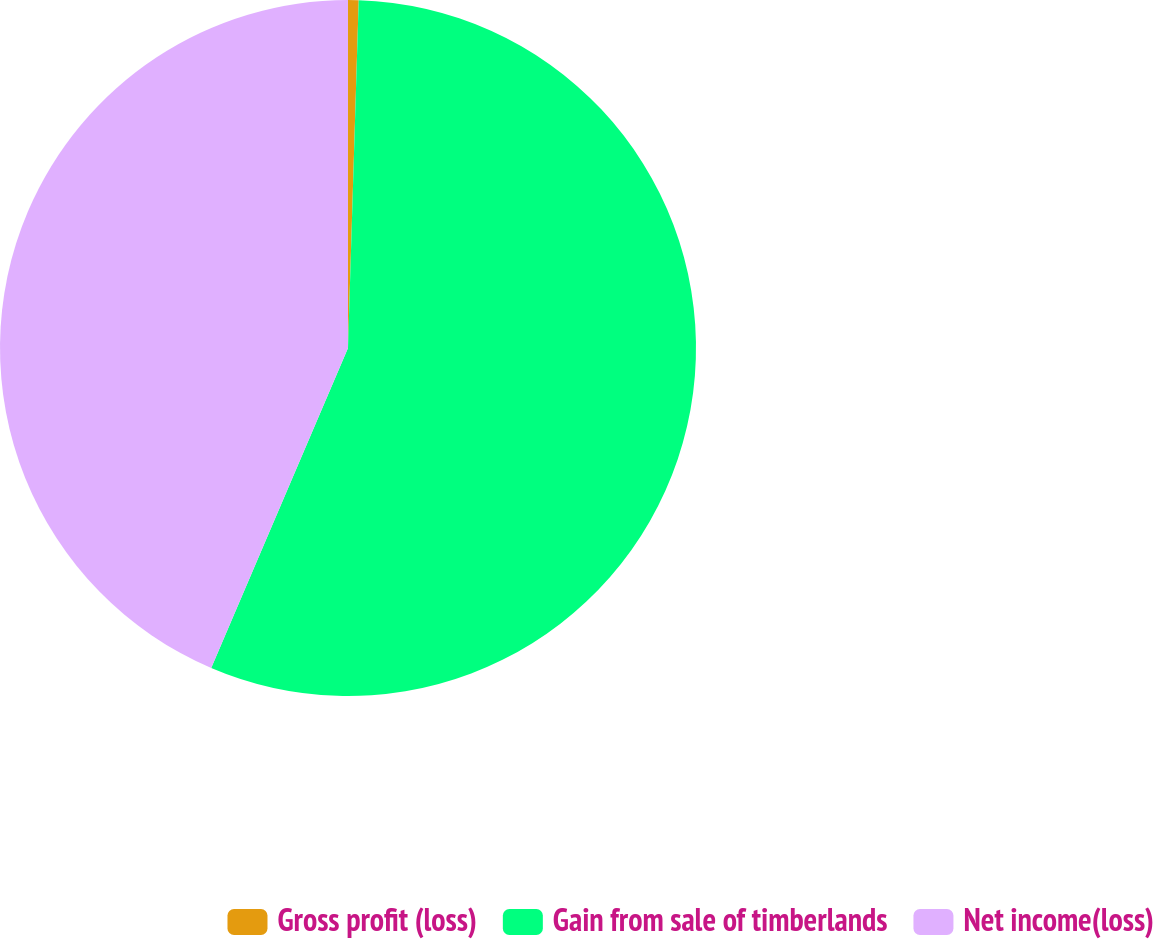Convert chart to OTSL. <chart><loc_0><loc_0><loc_500><loc_500><pie_chart><fcel>Gross profit (loss)<fcel>Gain from sale of timberlands<fcel>Net income(loss)<nl><fcel>0.49%<fcel>55.94%<fcel>43.57%<nl></chart> 